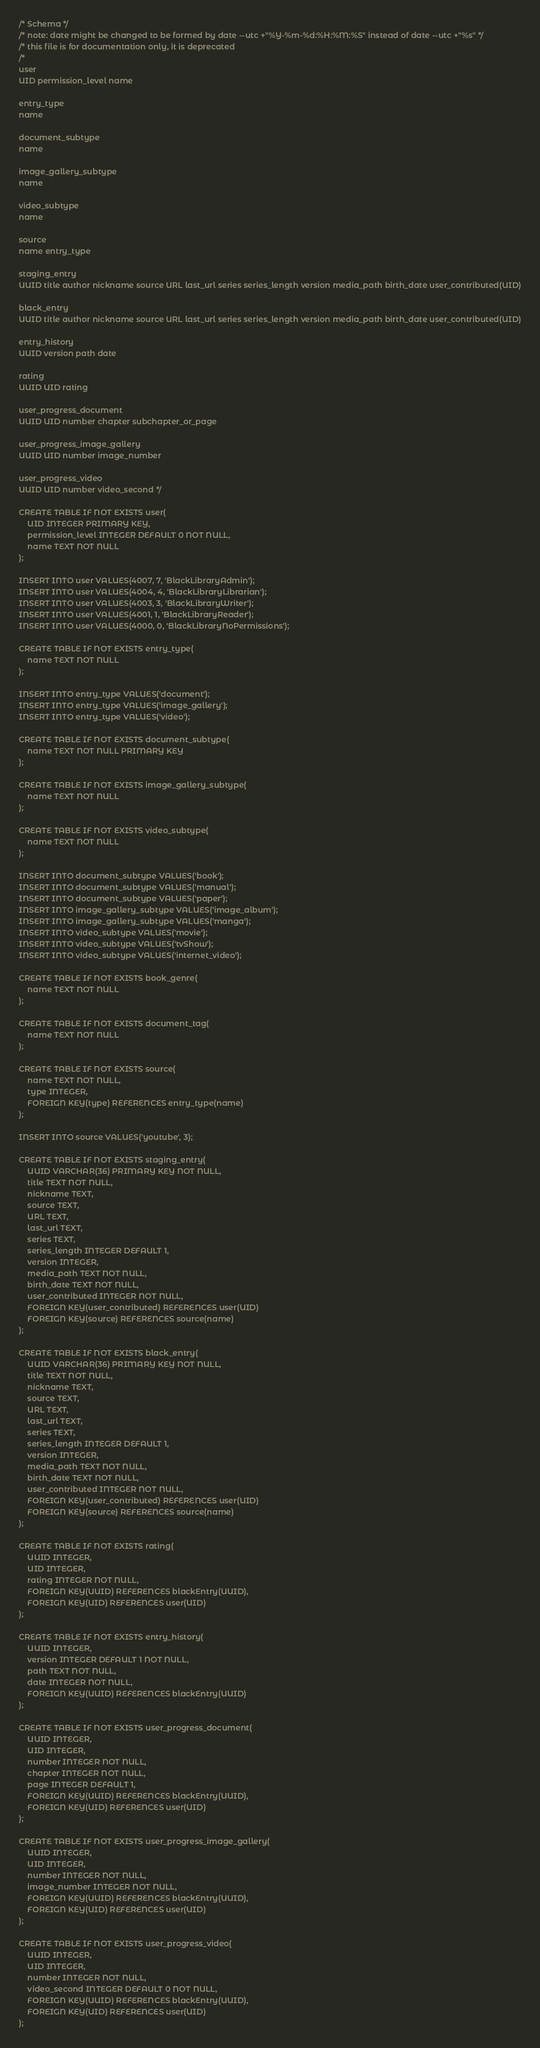Convert code to text. <code><loc_0><loc_0><loc_500><loc_500><_SQL_>/* Schema */
/* note: date might be changed to be formed by date --utc +"%Y-%m-%d:%H:%M:%S" instead of date --utc +"%s" */
/* this file is for documentation only, it is deprecated
/*
user
UID permission_level name

entry_type
name

document_subtype
name

image_gallery_subtype
name

video_subtype
name

source
name entry_type

staging_entry
UUID title author nickname source URL last_url series series_length version media_path birth_date user_contributed(UID)

black_entry
UUID title author nickname source URL last_url series series_length version media_path birth_date user_contributed(UID)

entry_history
UUID version path date

rating
UUID UID rating

user_progress_document
UUID UID number chapter subchapter_or_page

user_progress_image_gallery
UUID UID number image_number

user_progress_video
UUID UID number video_second */

CREATE TABLE IF NOT EXISTS user(
	UID INTEGER PRIMARY KEY, 
	permission_level INTEGER DEFAULT 0 NOT NULL, 
	name TEXT NOT NULL
);

INSERT INTO user VALUES(4007, 7, 'BlackLibraryAdmin');
INSERT INTO user VALUES(4004, 4, 'BlackLibraryLibrarian');
INSERT INTO user VALUES(4003, 3, 'BlackLibraryWriter');
INSERT INTO user VALUES(4001, 1, 'BlackLibraryReader');
INSERT INTO user VALUES(4000, 0, 'BlackLibraryNoPermissions');

CREATE TABLE IF NOT EXISTS entry_type(
    name TEXT NOT NULL
);

INSERT INTO entry_type VALUES('document');
INSERT INTO entry_type VALUES('image_gallery');
INSERT INTO entry_type VALUES('video');

CREATE TABLE IF NOT EXISTS document_subtype(
	name TEXT NOT NULL PRIMARY KEY
);

CREATE TABLE IF NOT EXISTS image_gallery_subtype(
	name TEXT NOT NULL
);

CREATE TABLE IF NOT EXISTS video_subtype(
	name TEXT NOT NULL
);

INSERT INTO document_subtype VALUES('book');
INSERT INTO document_subtype VALUES('manual');
INSERT INTO document_subtype VALUES('paper');
INSERT INTO image_gallery_subtype VALUES('image_album');
INSERT INTO image_gallery_subtype VALUES('manga');
INSERT INTO video_subtype VALUES('movie');
INSERT INTO video_subtype VALUES('tvShow');
INSERT INTO video_subtype VALUES('internet_video');

CREATE TABLE IF NOT EXISTS book_genre(
	name TEXT NOT NULL
);

CREATE TABLE IF NOT EXISTS document_tag(
	name TEXT NOT NULL
);

CREATE TABLE IF NOT EXISTS source(
	name TEXT NOT NULL, 
	type INTEGER,
	FOREIGN KEY(type) REFERENCES entry_type(name)
);

INSERT INTO source VALUES('youtube', 3);

CREATE TABLE IF NOT EXISTS staging_entry(
	UUID VARCHAR(36) PRIMARY KEY NOT NULL, 
	title TEXT NOT NULL, 
	nickname TEXT, 
	source TEXT, 
	URL TEXT, 
	last_url TEXT,
	series TEXT,
	series_length INTEGER DEFAULT 1,
	version INTEGER, 
	media_path TEXT NOT NULL, 
	birth_date TEXT NOT NULL, 
	user_contributed INTEGER NOT NULL, 
	FOREIGN KEY(user_contributed) REFERENCES user(UID)
	FOREIGN KEY(source) REFERENCES source(name)
);

CREATE TABLE IF NOT EXISTS black_entry(
	UUID VARCHAR(36) PRIMARY KEY NOT NULL, 
	title TEXT NOT NULL, 
	nickname TEXT, 
	source TEXT, 
	URL TEXT, 
	last_url TEXT,
	series TEXT,
	series_length INTEGER DEFAULT 1,
	version INTEGER, 
	media_path TEXT NOT NULL, 
	birth_date TEXT NOT NULL, 
	user_contributed INTEGER NOT NULL, 
	FOREIGN KEY(user_contributed) REFERENCES user(UID)
	FOREIGN KEY(source) REFERENCES source(name)
);

CREATE TABLE IF NOT EXISTS rating(
	UUID INTEGER, 
	UID INTEGER, 
	rating INTEGER NOT NULL,
	FOREIGN KEY(UUID) REFERENCES blackEntry(UUID), 
	FOREIGN KEY(UID) REFERENCES user(UID)
);

CREATE TABLE IF NOT EXISTS entry_history(
	UUID INTEGER, 
	version INTEGER DEFAULT 1 NOT NULL, 
	path TEXT NOT NULL, 
	date INTEGER NOT NULL, 
	FOREIGN KEY(UUID) REFERENCES blackEntry(UUID)
);

CREATE TABLE IF NOT EXISTS user_progress_document(
	UUID INTEGER, 
	UID INTEGER, 
	number INTEGER NOT NULL, 
	chapter INTEGER NOT NULL, 
	page INTEGER DEFAULT 1, 
	FOREIGN KEY(UUID) REFERENCES blackEntry(UUID),
	FOREIGN KEY(UID) REFERENCES user(UID)
);

CREATE TABLE IF NOT EXISTS user_progress_image_gallery(
	UUID INTEGER,
	UID INTEGER,
	number INTEGER NOT NULL,
	image_number INTEGER NOT NULL,
	FOREIGN KEY(UUID) REFERENCES blackEntry(UUID), 
	FOREIGN KEY(UID) REFERENCES user(UID)
);

CREATE TABLE IF NOT EXISTS user_progress_video(
	UUID INTEGER,
	UID INTEGER,
	number INTEGER NOT NULL,
	video_second INTEGER DEFAULT 0 NOT NULL,
	FOREIGN KEY(UUID) REFERENCES blackEntry(UUID), 
	FOREIGN KEY(UID) REFERENCES user(UID)
);
</code> 